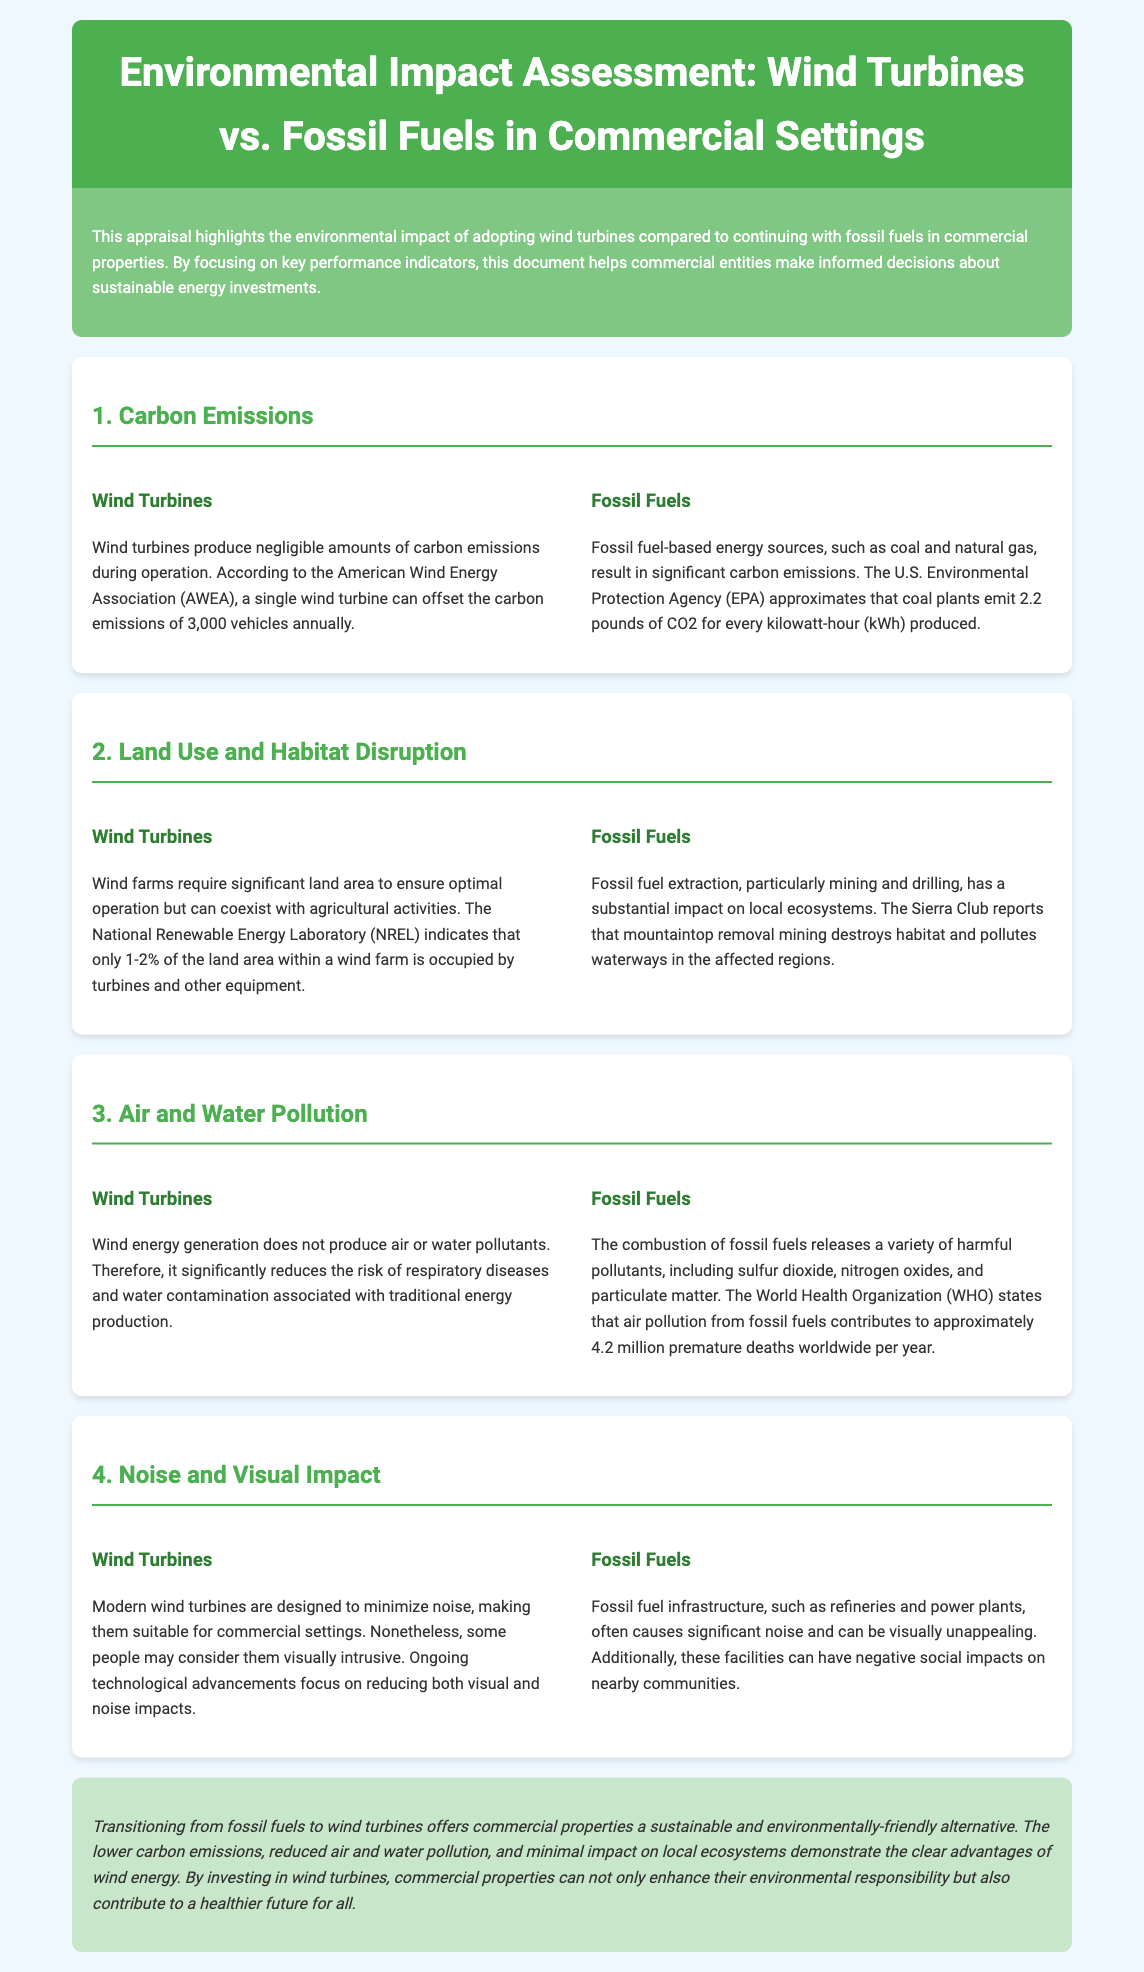What is the primary focus of the appraisal? The appraisal focuses on comparing the environmental impact of wind turbines and fossil fuels in commercial settings.
Answer: Comparing environmental impact How many pounds of CO2 do coal plants emit for every kilowatt-hour produced? According to the U.S. Environmental Protection Agency, coal plants emit 2.2 pounds of CO2 for every kilowatt-hour produced.
Answer: 2.2 pounds What percentage of land area within a wind farm is occupied by turbines and equipment? The National Renewable Energy Laboratory states only 1-2% of land area is occupied by turbines and other equipment in a wind farm.
Answer: 1-2% What pollutants are released by the combustion of fossil fuels? The document mentions that the combustion of fossil fuels releases sulfur dioxide, nitrogen oxides, and particulate matter.
Answer: Sulfur dioxide, nitrogen oxides, particulate matter What is one advantage of modern wind turbines regarding sound? Wind turbines are designed to minimize noise, making them suitable for commercial settings.
Answer: Minimize noise How does wind energy impact air pollution compared to fossil fuels? Wind energy generation does not produce air pollutants, significantly reducing risks associated with traditional energy production.
Answer: No air pollutants What does the World Health Organization estimate about air pollution from fossil fuels? The WHO states that air pollution from fossil fuels contributes to approximately 4.2 million premature deaths worldwide per year.
Answer: 4.2 million deaths Why might people consider wind turbines visually intrusive? Some people may consider wind turbines visually intrusive, despite ongoing technological advancements addressing this issue.
Answer: Visually intrusive What is the conclusion about transitioning to wind energy? The conclusion highlights that transitioning to wind turbines offers sustainable and environmentally-friendly alternatives with clear advantages.
Answer: Sustainable and environmentally-friendly alternatives 